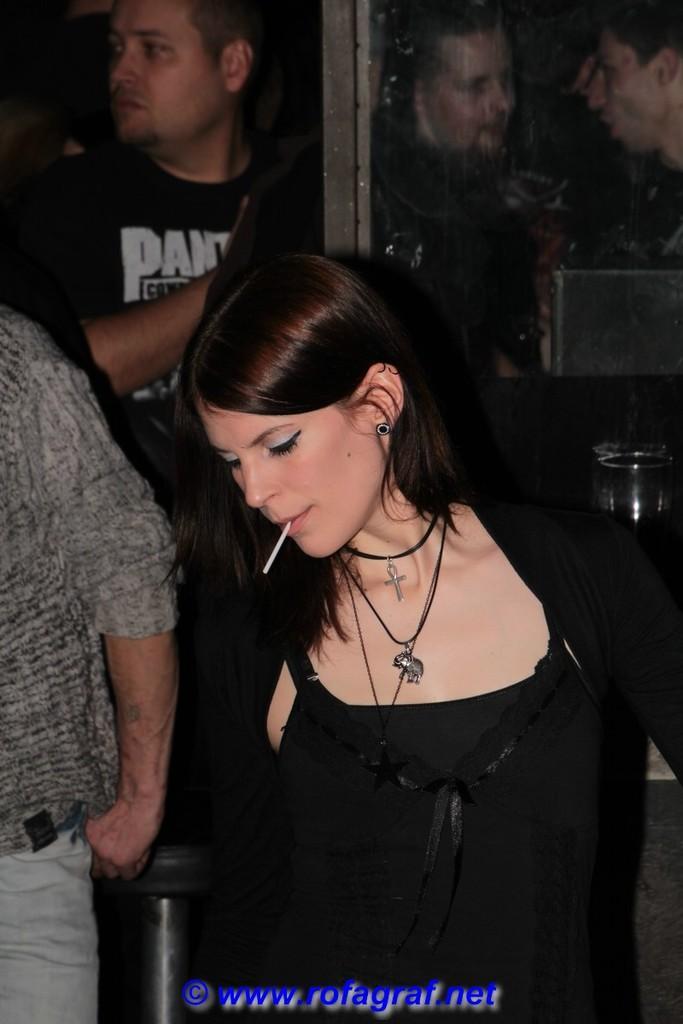Describe this image in one or two sentences. In this image there are some persons are standing as we can see in middle of this image and the women standing at bottom of this image is wearing black color dress and there is a logo with some text at bottom of this image and there is a glass door at top right corner of this image. 